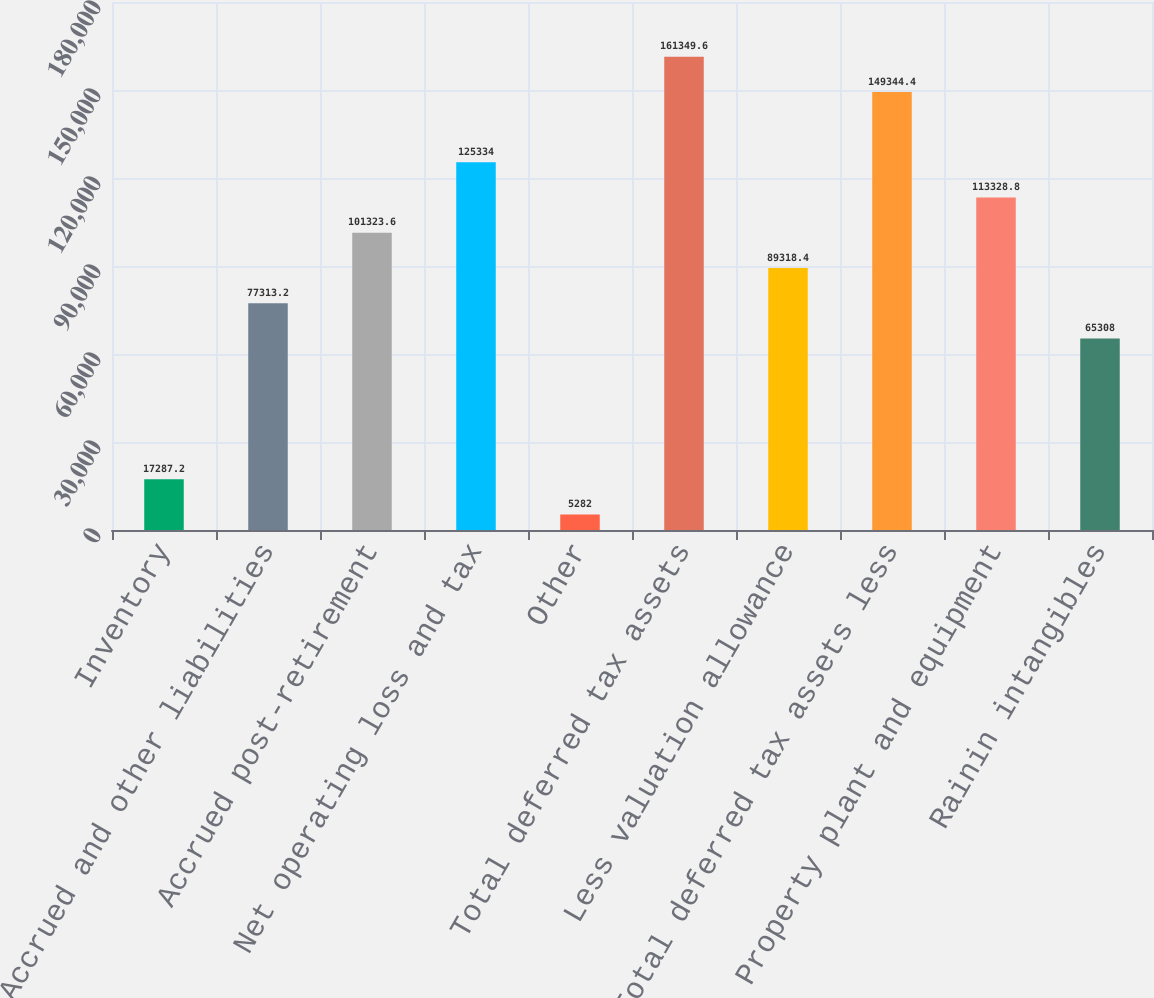<chart> <loc_0><loc_0><loc_500><loc_500><bar_chart><fcel>Inventory<fcel>Accrued and other liabilities<fcel>Accrued post-retirement<fcel>Net operating loss and tax<fcel>Other<fcel>Total deferred tax assets<fcel>Less valuation allowance<fcel>Total deferred tax assets less<fcel>Property plant and equipment<fcel>Rainin intangibles<nl><fcel>17287.2<fcel>77313.2<fcel>101324<fcel>125334<fcel>5282<fcel>161350<fcel>89318.4<fcel>149344<fcel>113329<fcel>65308<nl></chart> 